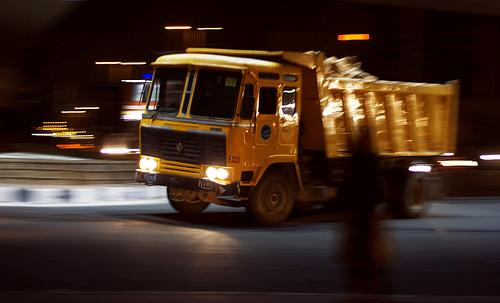How many windows are present on the truck, and can you provide a brief description of their placement? There are four windows on the truck - two on the windshield at the front, one on the driver's side, and one on the passenger's side. What are some unique features of the truck in terms of appearance or functionality? The truck has a yellow arm, an orange lit-up light above it, and a blue decal on its door, making it easily identifiable as a construction dump truck. Briefly describe the truck's tires and their positioning. There are two visible tires, one black rear tire on the left of the truck and another tire on the right side. Identify the primary vehicle and its appearance in the image. A yellow construction dump truck in motion with a blue decal on the door, a black grill, and four lit headlights. Is there any indication of the truck's movement or position on the road? Yes, it is a dump truck driving on the road with some part of the road visible in the image. Based on the image, what is the sentiment or mood conveyed by the scene? The scene conveys a sense of activity and motion, with the construction truck driving and its lights lit up. Describe any noticeable features on the front of the truck. The front of the truck has two headlights on each side, a black grill, and a windshield with two windows. What are the lighting conditions in the image and how are they affecting the objects in it? There is an orange light over the truck and a reflection of light on the pavement, indicating that the scene is brightly lit. Count the number of lights visible on the truck and describe their appearance. There are four visible lights: two on the left and two on the right, all lit and placed at the front of the truck. Describe any decals and their locations on the truck. There is a blue decal on the truck's door, near the middle of the vehicle. How many of the truck's lights are functioning properly? All four lights on the truck are functioning properly and lit up. Invent a scenario about why the truck is driving on the street. The truck is transporting construction material from a construction site to another location. Identify the color and location of the truck's grill. The truck has a black grill and it is located at the front of the truck. Is there an animal standing beside the dump truck? There is no mention of any animals in the given data, only elements related to the truck are mentioned. Are the truck's front tires on the right side of the truck white? There is no mention of white tires in the given data, only black rear tire on the left of the truck is mentioned. Explain the function of the yellow arm on the truck. The yellow arm is used for lifting or moving heavy objects. Describe the type and color of the tires on the truck. The tires are black and appear to be standard for a large construction truck. Create a sentence that describes the dump truck's appearance and activity. The large yellow dump truck is driving on the street with its headlights illuminated. What is the color of the truck's rear tire on the left side? The rear tire on the left side of the truck is black. How many headlights are lit up on the front of the truck? Four headlights are lit up on the front of the truck. Is there a person sitting inside the truck's cabin? There is no mention of a person in the given data, only elements such as windows, decals, and lights on the truck are mentioned. Is there a motorcycle next to the dump truck? There is no mention of a motorcycle in the given data, only a dump truck is mentioned. What is the main action happening in the image? A dump truck is driving on the road. What color is the construction truck in the image? Yellow What is the shape of the decal on the truck's door? The decal is circular. State the color and location of the truck's windshield. The windshield is located on the front of the truck, and its color cannot be determined. Describe the object that is emitting light above the truck. An orange lit up light is above the truck. What kind of street infrastructure can be identified in the image? There is a reflection of light on the pavement. Is the green dump truck driving on the street? There is no mention of a green dump truck in the given data, only yellow dump trucks are mentioned. Can you see a red light on the right of the truck? There is no mention of a red light on the right of the truck, only headlights and orange lit up light above the truck are mentioned. Count the number of windows visible on the truck. There are 4 windows visible on the truck. Which of the following is the truck in the image? A) Dump truck B) Fire truck C) Tow truck D) Ambulance A) Dump truck Describe the position and appearance of the blue decal on the dump truck. The blue decal is located on the door of the truck. Mention any unique features of the truck's windows. No unique features can be identified in the truck's windows. 